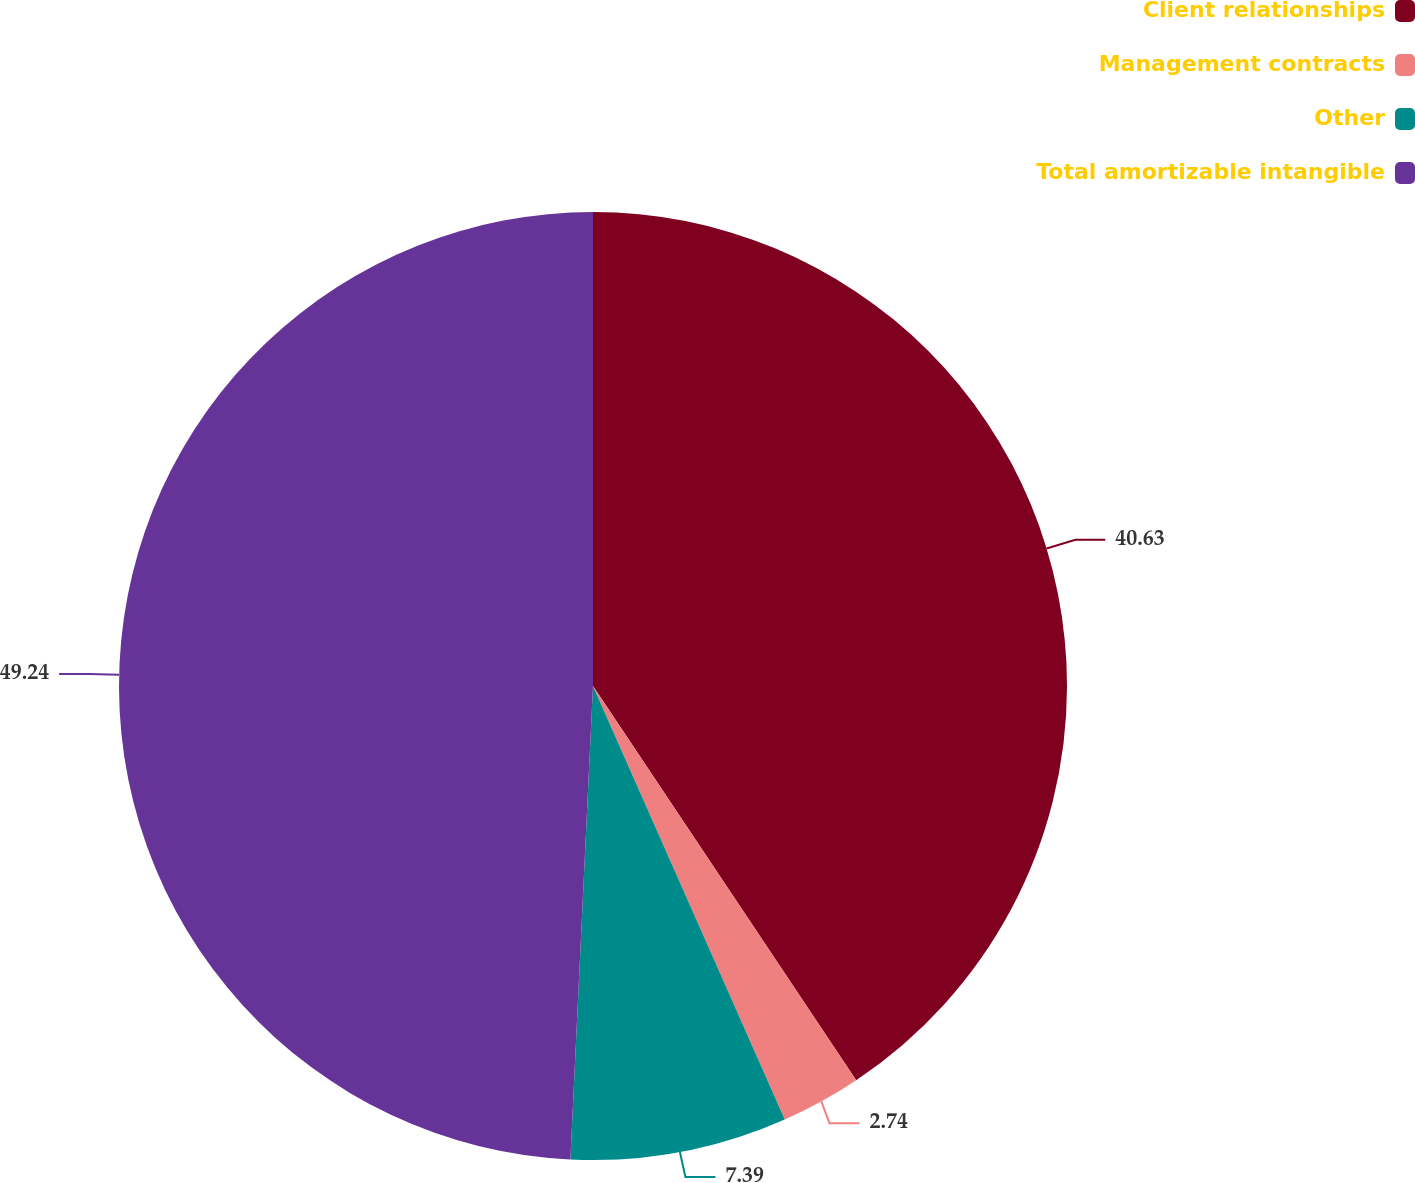<chart> <loc_0><loc_0><loc_500><loc_500><pie_chart><fcel>Client relationships<fcel>Management contracts<fcel>Other<fcel>Total amortizable intangible<nl><fcel>40.63%<fcel>2.74%<fcel>7.39%<fcel>49.24%<nl></chart> 